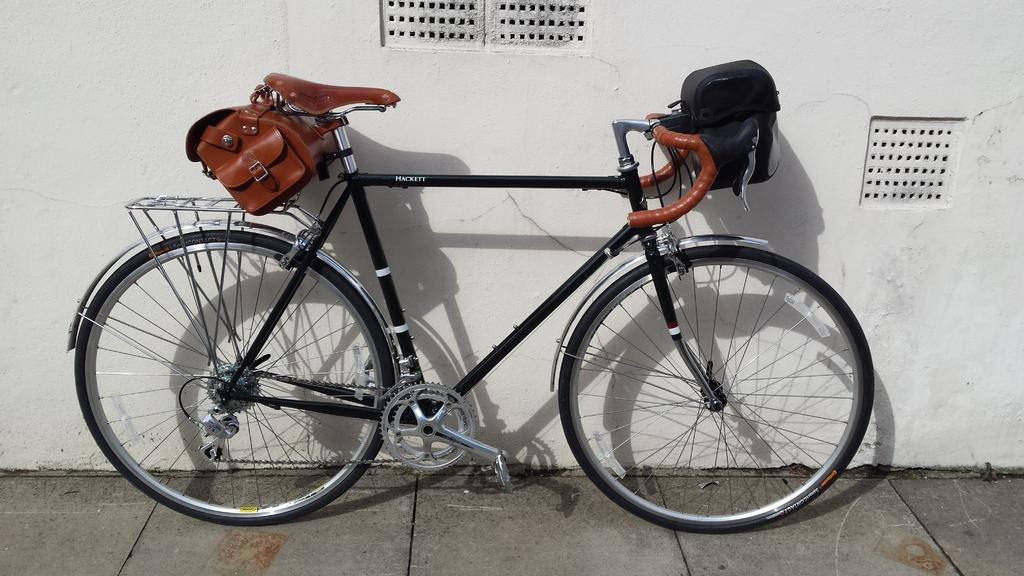What is the main object in the image? There is a bicycle in the image. Are there any additional items visible in the image? Yes, there are two bags in the image. What type of surface is visible at the bottom of the image? The bottom of the image shows a pavement. What can be seen in the background of the image? There is a wall visible in the background of the image. Can you see a snake slithering down the slope in the image? There is no snake or slope present in the image. 